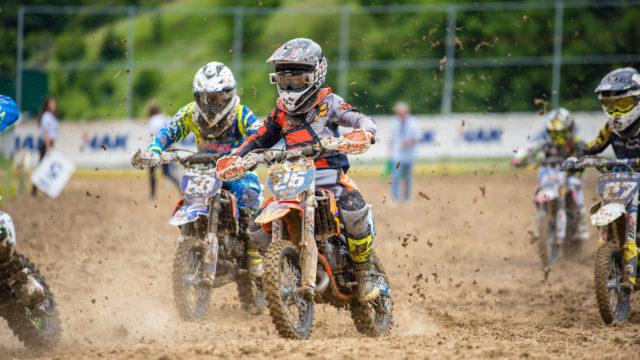How many motorbikes would there be in the image after one more motorbike has been added in the image? After studying the image carefully, if an additional motorbike were to join the scene, there would be a total of 5 motorbikes. This answer takes into account the existing number of bikes in the visual composition at the time of the question. 